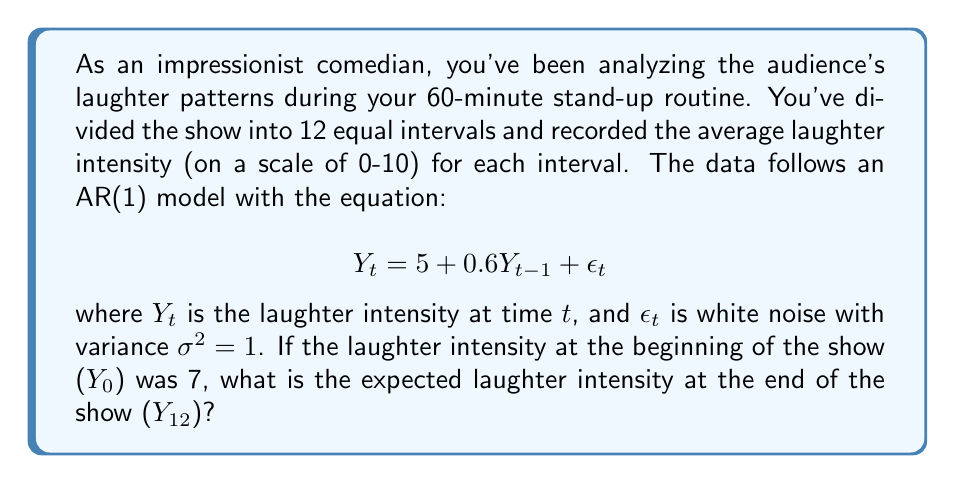Can you solve this math problem? To solve this problem, we need to use the properties of AR(1) models and iterate the equation for 12 time steps. Let's break it down:

1) First, recall that for an AR(1) model of the form $Y_t = c + \phi Y_{t-1} + \epsilon_t$, the expected value at time $t$ is given by:

   $$E[Y_t] = \frac{c}{1-\phi} + \phi^t(Y_0 - \frac{c}{1-\phi})$$

   where $c$ is the constant term, $\phi$ is the AR coefficient, and $Y_0$ is the initial value.

2) In our case, $c = 5$, $\phi = 0.6$, and $Y_0 = 7$.

3) Let's calculate $\frac{c}{1-\phi}$:

   $$\frac{c}{1-\phi} = \frac{5}{1-0.6} = \frac{5}{0.4} = 12.5$$

4) Now we can plug everything into the formula:

   $$E[Y_{12}] = 12.5 + 0.6^{12}(7 - 12.5)$$

5) Let's calculate $0.6^{12}$:

   $$0.6^{12} \approx 0.0022$$

6) Now we can finish the calculation:

   $$E[Y_{12}] = 12.5 + 0.0022(7 - 12.5)$$
   $$= 12.5 + 0.0022(-5.5)$$
   $$= 12.5 - 0.0121$$
   $$= 12.4879$$

7) Rounding to two decimal places, we get 12.49.
Answer: The expected laughter intensity at the end of the show ($Y_{12}$) is approximately 12.49. 